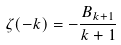<formula> <loc_0><loc_0><loc_500><loc_500>\zeta ( - k ) = - \frac { B _ { k + 1 } } { k + 1 }</formula> 